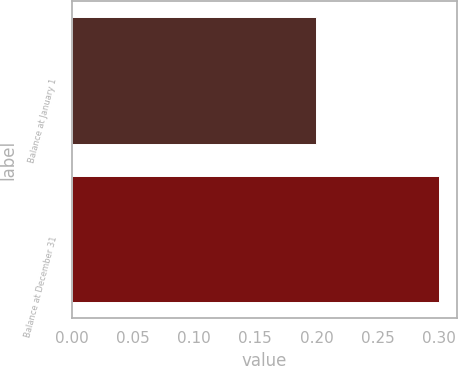Convert chart to OTSL. <chart><loc_0><loc_0><loc_500><loc_500><bar_chart><fcel>Balance at January 1<fcel>Balance at December 31<nl><fcel>0.2<fcel>0.3<nl></chart> 